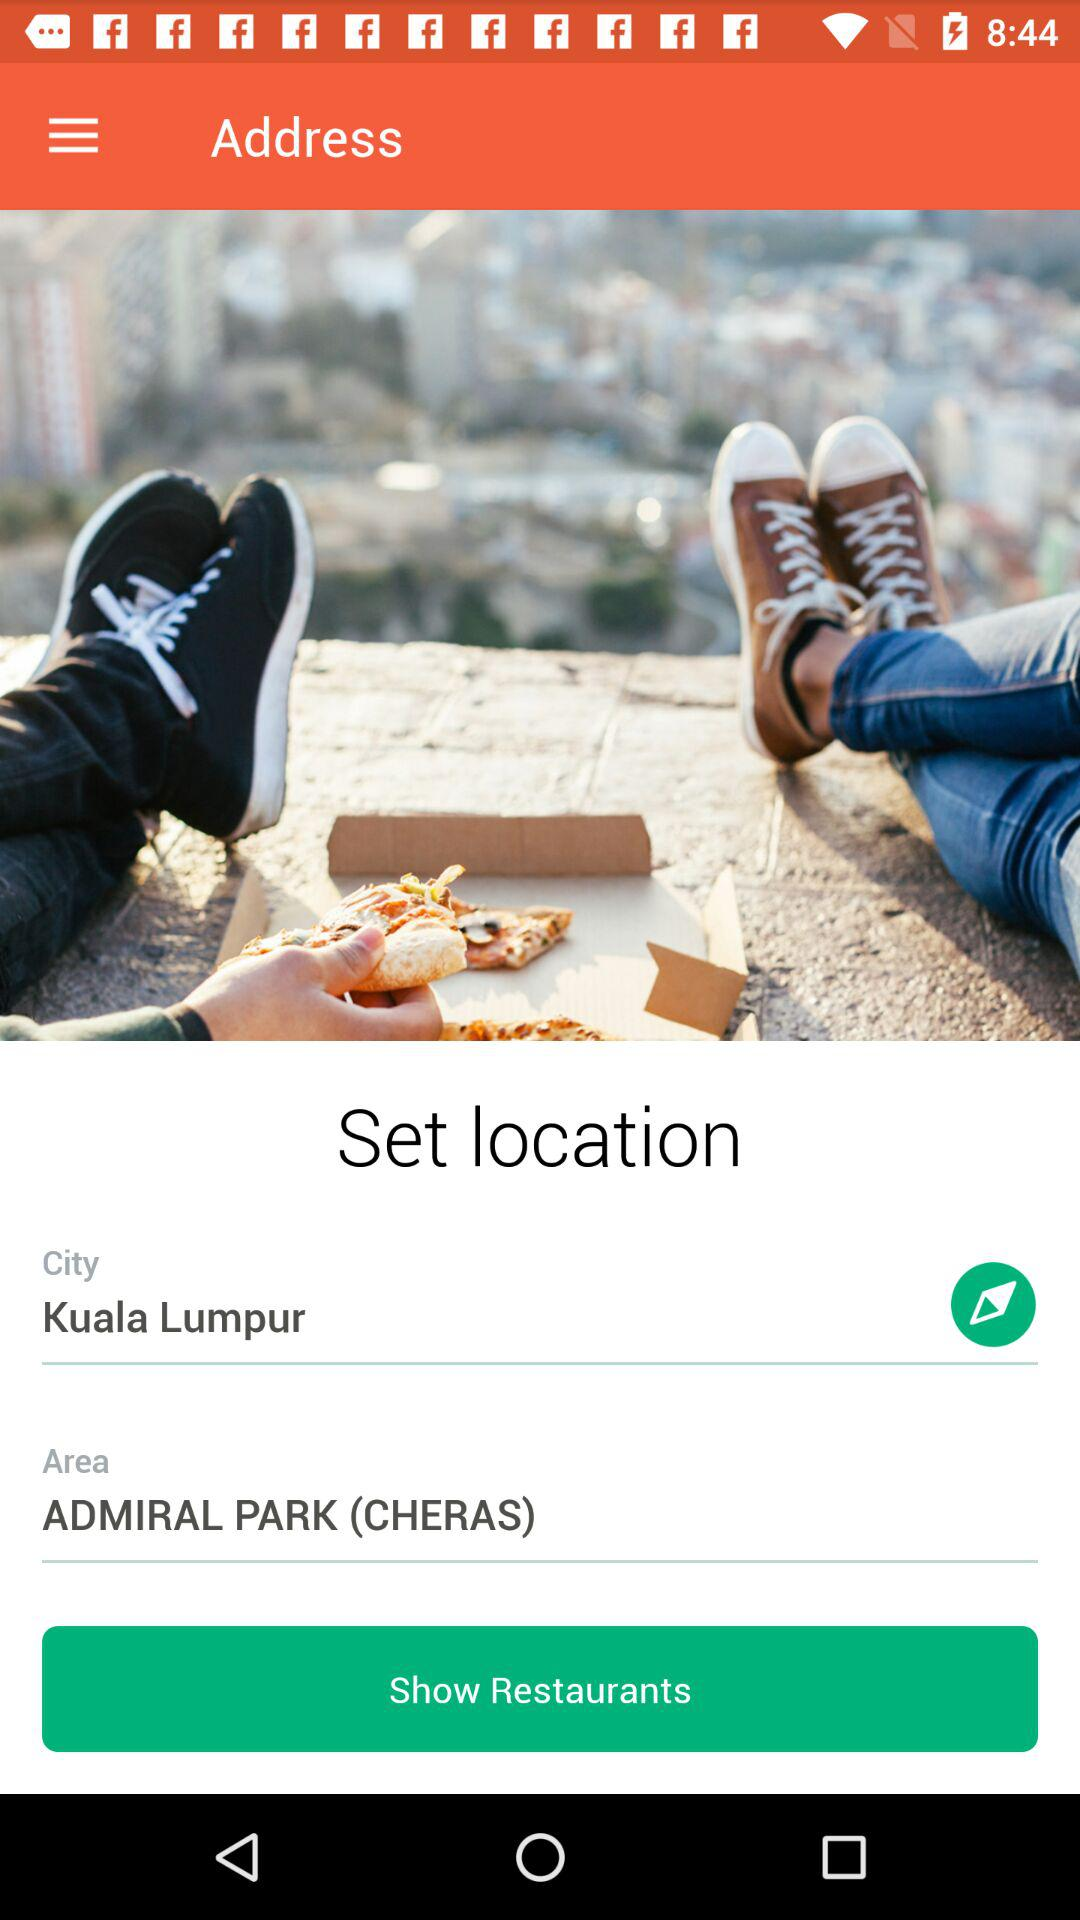What is the city name? The city name is Kuala Lumpur. 